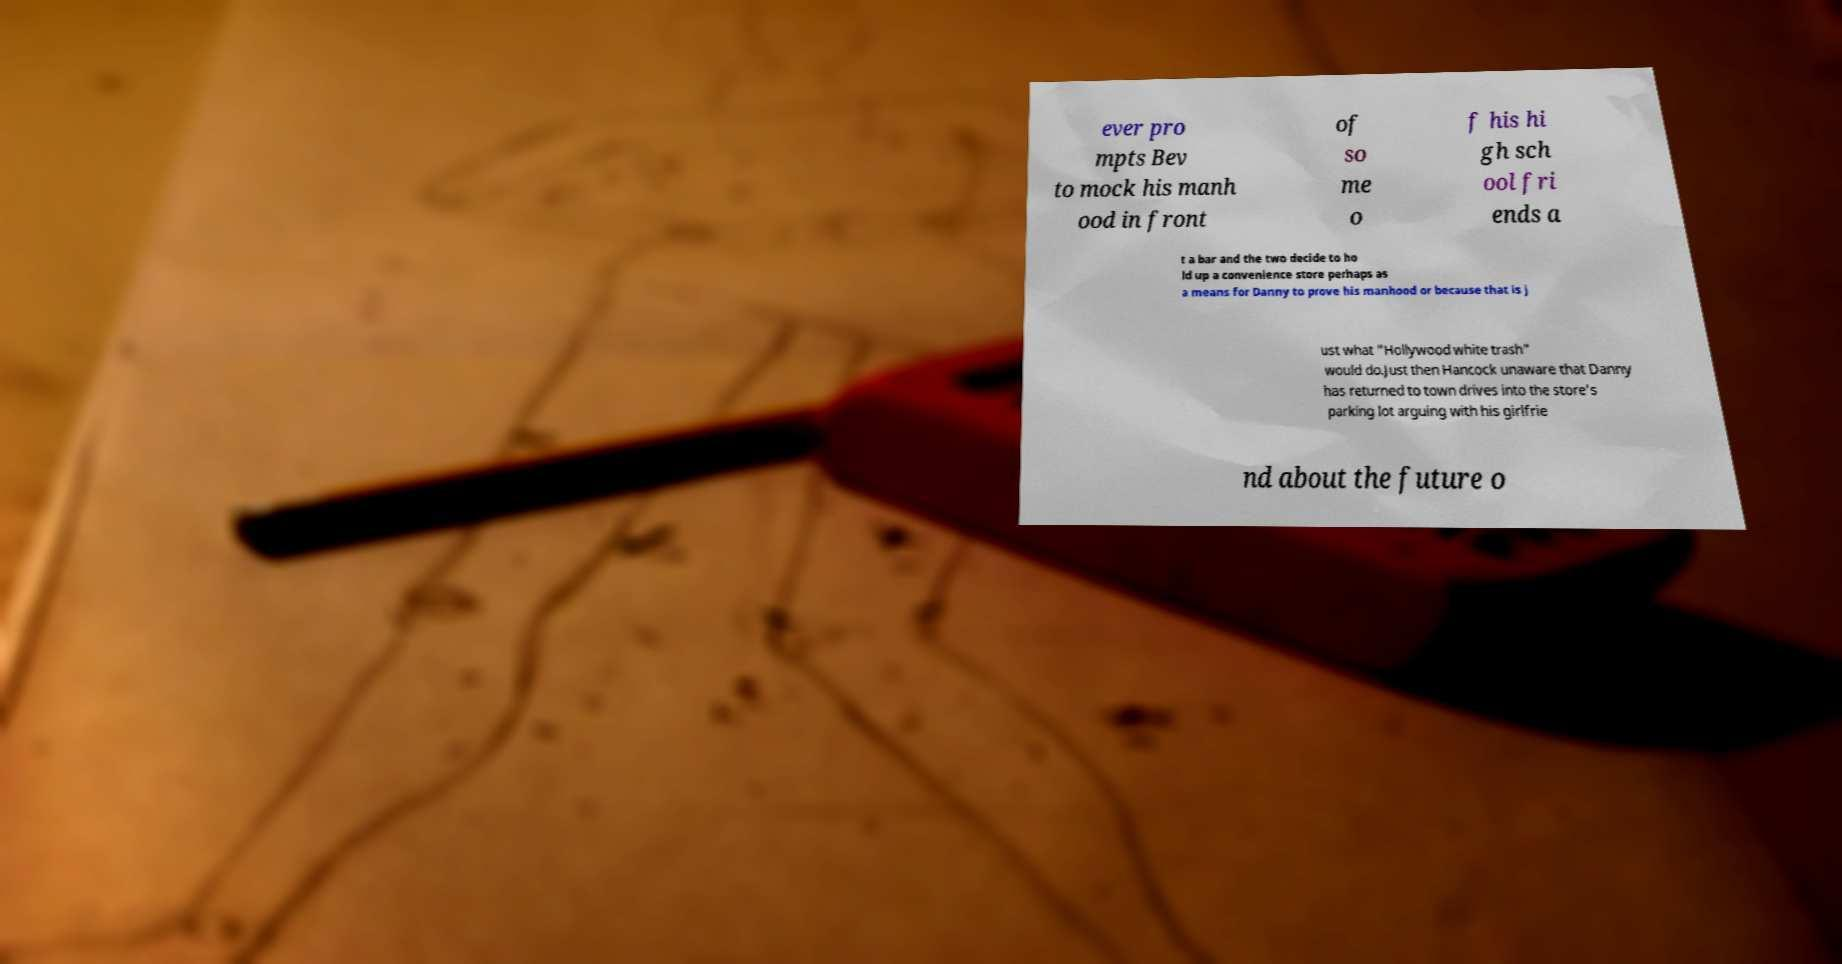Could you extract and type out the text from this image? ever pro mpts Bev to mock his manh ood in front of so me o f his hi gh sch ool fri ends a t a bar and the two decide to ho ld up a convenience store perhaps as a means for Danny to prove his manhood or because that is j ust what "Hollywood white trash" would do.Just then Hancock unaware that Danny has returned to town drives into the store's parking lot arguing with his girlfrie nd about the future o 